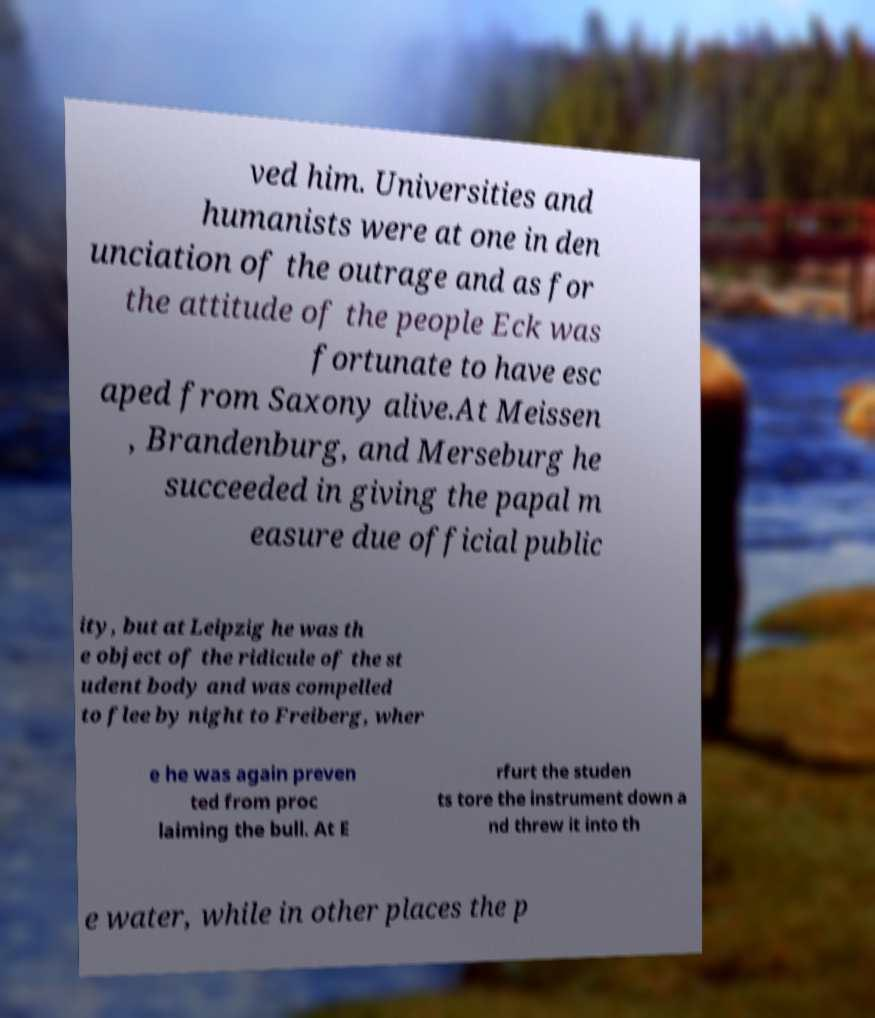Could you extract and type out the text from this image? ved him. Universities and humanists were at one in den unciation of the outrage and as for the attitude of the people Eck was fortunate to have esc aped from Saxony alive.At Meissen , Brandenburg, and Merseburg he succeeded in giving the papal m easure due official public ity, but at Leipzig he was th e object of the ridicule of the st udent body and was compelled to flee by night to Freiberg, wher e he was again preven ted from proc laiming the bull. At E rfurt the studen ts tore the instrument down a nd threw it into th e water, while in other places the p 